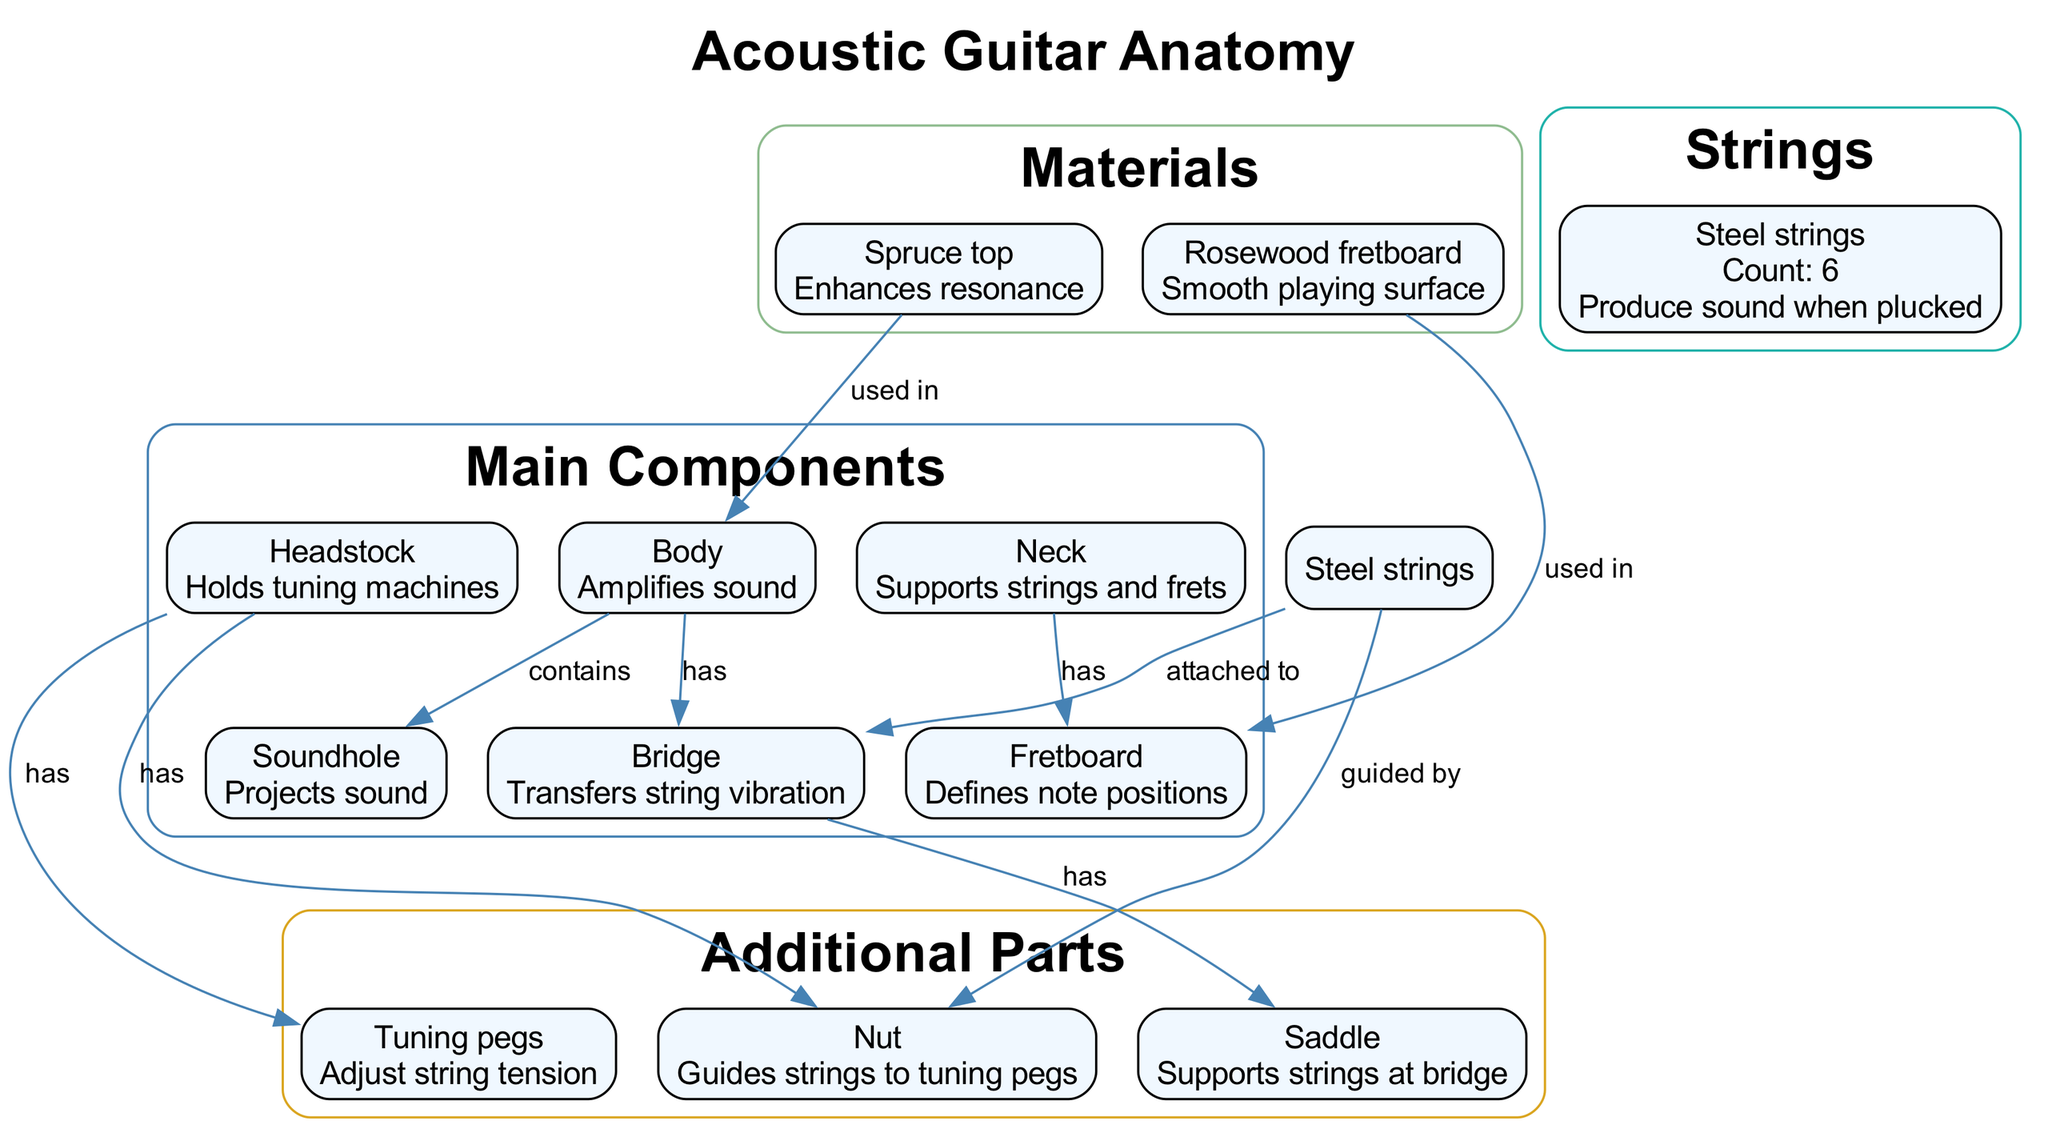What is the function of the Body? The diagram states that the Body amplifies sound, which is a primary function indicated next to the Body component in the main components section.
Answer: Amplifies sound How many strings does the guitar have? The diagram shows that the guitar has 6 Steel strings, with the count explicitly labeled in the strings section of the diagram.
Answer: 6 What part guides the strings to the tuning pegs? According to the diagram, the Nut is responsible for guiding strings to the tuning pegs, as mentioned next to the label in the additional parts section.
Answer: Nut What function does the Soundhole serve? The diagram specifies that the Soundhole projects sound, which is noted as its function in the main components of the diagram.
Answer: Projects sound Which material is used in the Fretboard? The diagram indicates that Rosewood is used in the Fretboard, highlighted under the materials section, and this is a specific relationship mentioned in the diagram.
Answer: Rosewood What is the relationship between the Neck and the Fretboard? The diagram illustrates that the Neck has the Fretboard, establishing a clear relationship labeled between these two components. This connects the Neck to its primary purpose of supporting the strings and frets.
Answer: has How does the Bridge interact with the Saddle? The diagram shows that the Bridge has the Saddle, which indicates that the Saddle supports the strings at the bridge as part of their interaction described in the additional parts cluster.
Answer: has What is the primary function of the Tuning pegs? The diagram states that the Tuning pegs adjust string tension, which is clearly mentioned next to the Tuning pegs in the additional parts section of the diagram.
Answer: Adjust string tension Which component enhances resonance? The diagram identifies the Spruce top as enhancing resonance, which appears in the materials section with its specific function detailed next to it.
Answer: Spruce top 